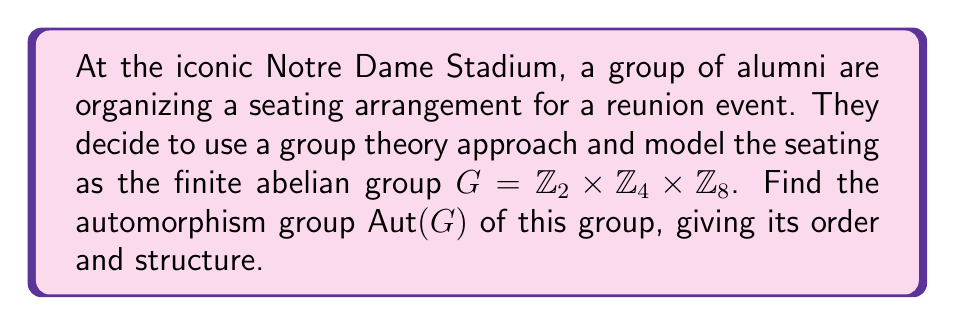Could you help me with this problem? To find the automorphism group of $G = \mathbb{Z}_2 \times \mathbb{Z}_4 \times \mathbb{Z}_8$, we'll follow these steps:

1) First, recall that for a finite abelian group $H = \mathbb{Z}_{p_1^{a_1}} \times \mathbb{Z}_{p_2^{a_2}} \times \cdots \times \mathbb{Z}_{p_k^{a_k}}$ where $p_1, p_2, \ldots, p_k$ are primes (not necessarily distinct), we have:

   $\text{Aut}(H) \cong \text{GL}(a_1, \mathbb{Z}_{p_1}) \times \text{GL}(a_2, \mathbb{Z}_{p_2}) \times \cdots \times \text{GL}(a_k, \mathbb{Z}_{p_k})$

2) In our case, $G = \mathbb{Z}_2 \times \mathbb{Z}_4 \times \mathbb{Z}_8 = \mathbb{Z}_{2^1} \times \mathbb{Z}_{2^2} \times \mathbb{Z}_{2^3}$

3) Therefore, $\text{Aut}(G) \cong \text{GL}(1, \mathbb{Z}_2) \times \text{GL}(1, \mathbb{Z}_2) \times \text{GL}(1, \mathbb{Z}_2)$

4) Now, $\text{GL}(1, \mathbb{Z}_2)$ is the group of units of $\mathbb{Z}_2$, which has order 1.

5) $\text{GL}(1, \mathbb{Z}_4)$ is the group of units of $\mathbb{Z}_4$, which has order 2.

6) $\text{GL}(1, \mathbb{Z}_8)$ is the group of units of $\mathbb{Z}_8$, which has order 4.

7) Therefore, $|\text{Aut}(G)| = 1 \cdot 2 \cdot 4 = 8$

8) The structure of $\text{Aut}(G)$ is isomorphic to $\mathbb{Z}_2 \times \mathbb{Z}_4$, as this is the only abelian group of order 8 that fits the structure we've derived.
Answer: $\text{Aut}(G) \cong \mathbb{Z}_2 \times \mathbb{Z}_4$, with order 8. 